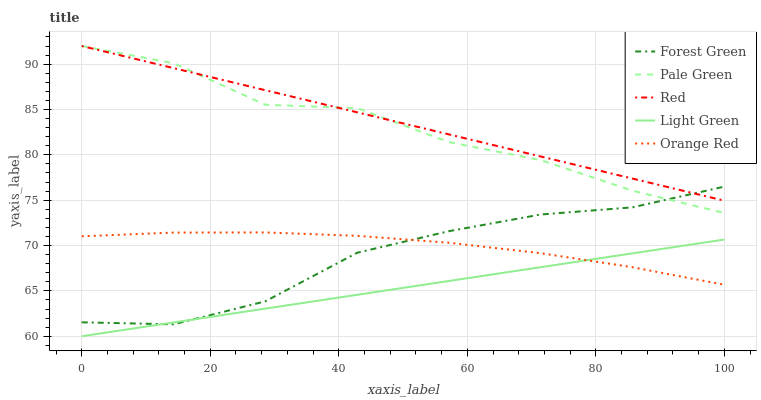Does Light Green have the minimum area under the curve?
Answer yes or no. Yes. Does Red have the maximum area under the curve?
Answer yes or no. Yes. Does Pale Green have the minimum area under the curve?
Answer yes or no. No. Does Pale Green have the maximum area under the curve?
Answer yes or no. No. Is Light Green the smoothest?
Answer yes or no. Yes. Is Pale Green the roughest?
Answer yes or no. Yes. Is Pale Green the smoothest?
Answer yes or no. No. Is Light Green the roughest?
Answer yes or no. No. Does Light Green have the lowest value?
Answer yes or no. Yes. Does Pale Green have the lowest value?
Answer yes or no. No. Does Red have the highest value?
Answer yes or no. Yes. Does Light Green have the highest value?
Answer yes or no. No. Is Orange Red less than Pale Green?
Answer yes or no. Yes. Is Pale Green greater than Light Green?
Answer yes or no. Yes. Does Pale Green intersect Red?
Answer yes or no. Yes. Is Pale Green less than Red?
Answer yes or no. No. Is Pale Green greater than Red?
Answer yes or no. No. Does Orange Red intersect Pale Green?
Answer yes or no. No. 